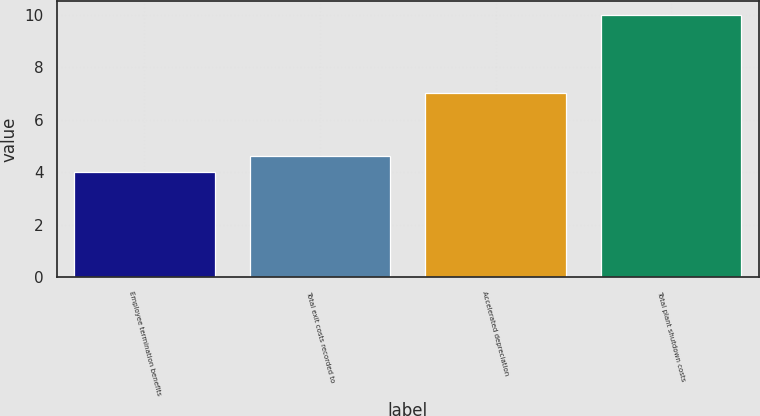<chart> <loc_0><loc_0><loc_500><loc_500><bar_chart><fcel>Employee termination benefits<fcel>Total exit costs recorded to<fcel>Accelerated depreciation<fcel>Total plant shutdown costs<nl><fcel>4<fcel>4.6<fcel>7<fcel>10<nl></chart> 